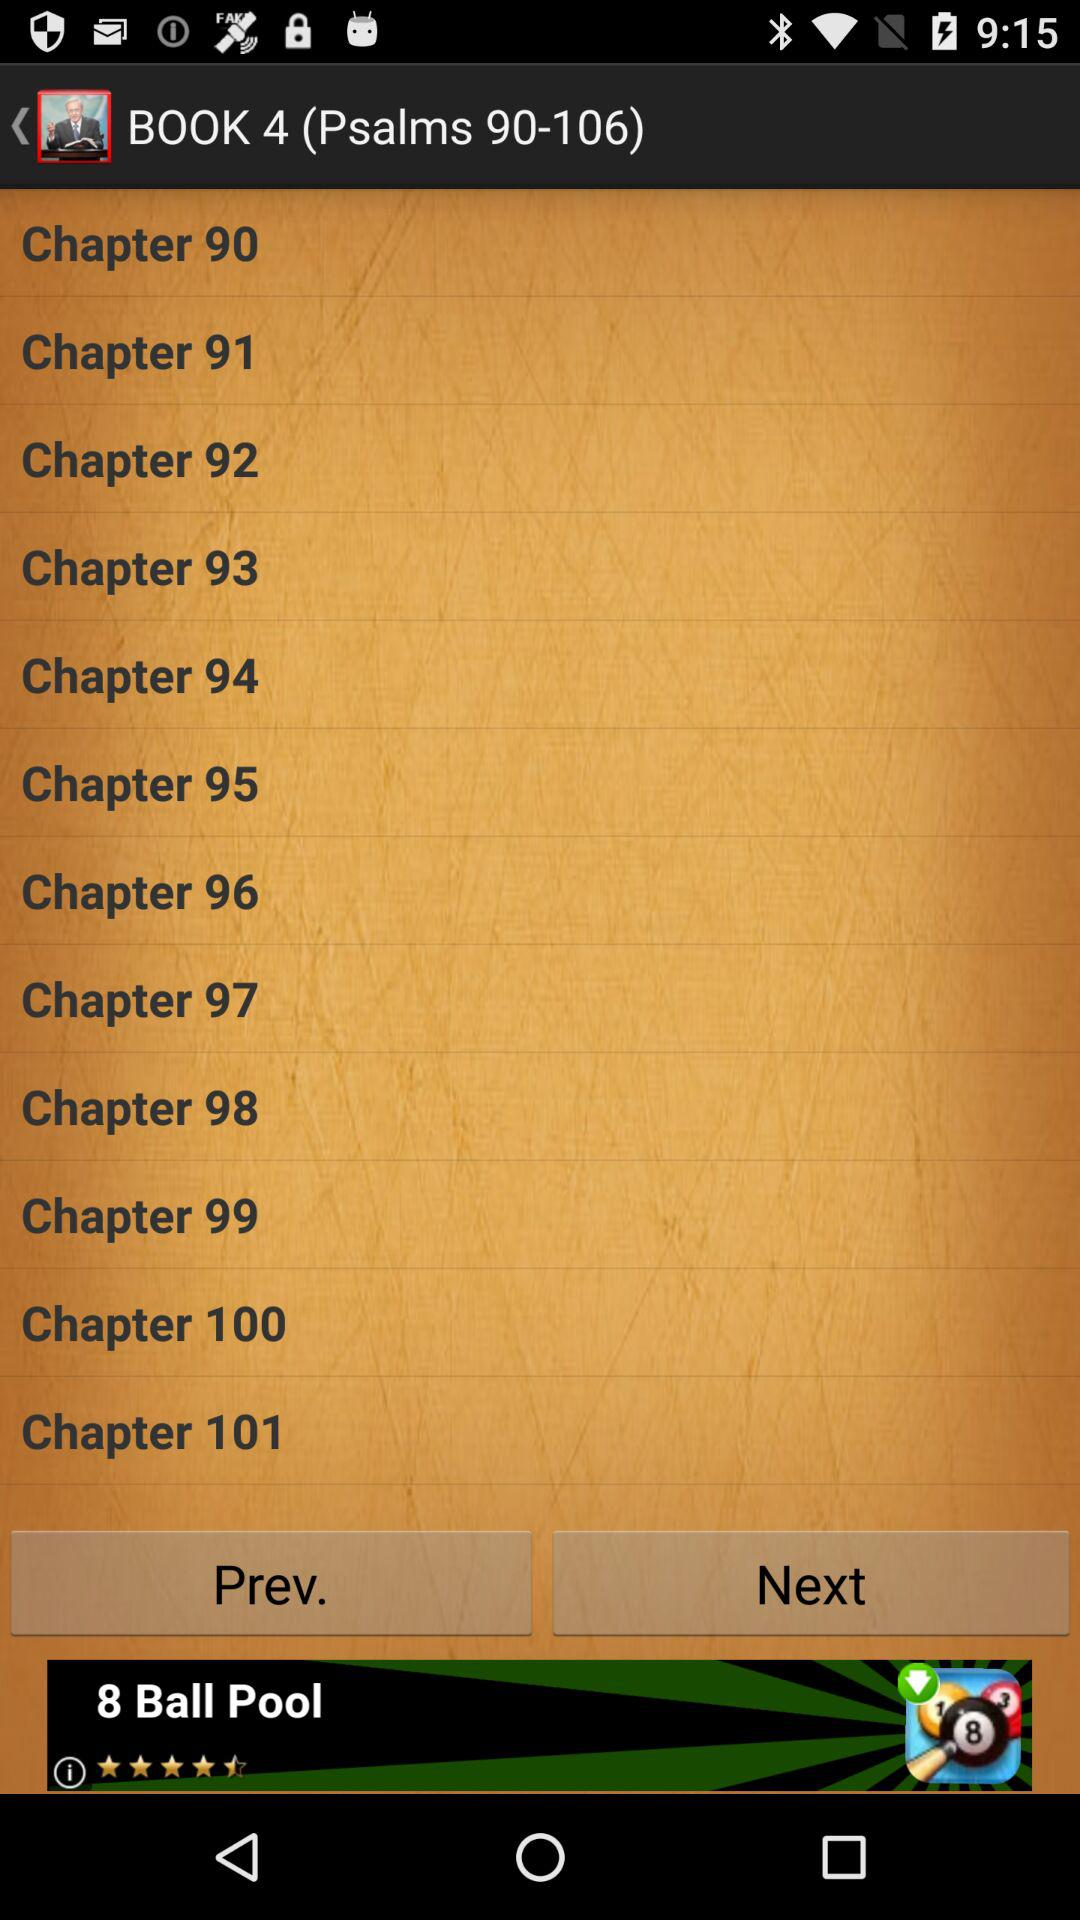How many quotes in total are there? There are 271 quotes. 